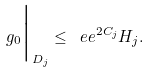Convert formula to latex. <formula><loc_0><loc_0><loc_500><loc_500>g _ { 0 } \Big | _ { D _ { j } } \leq \ e e ^ { 2 C _ { j } } H _ { j } .</formula> 